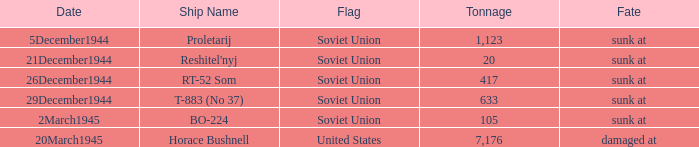What is the average tonnage of the ship named proletarij? 1123.0. 